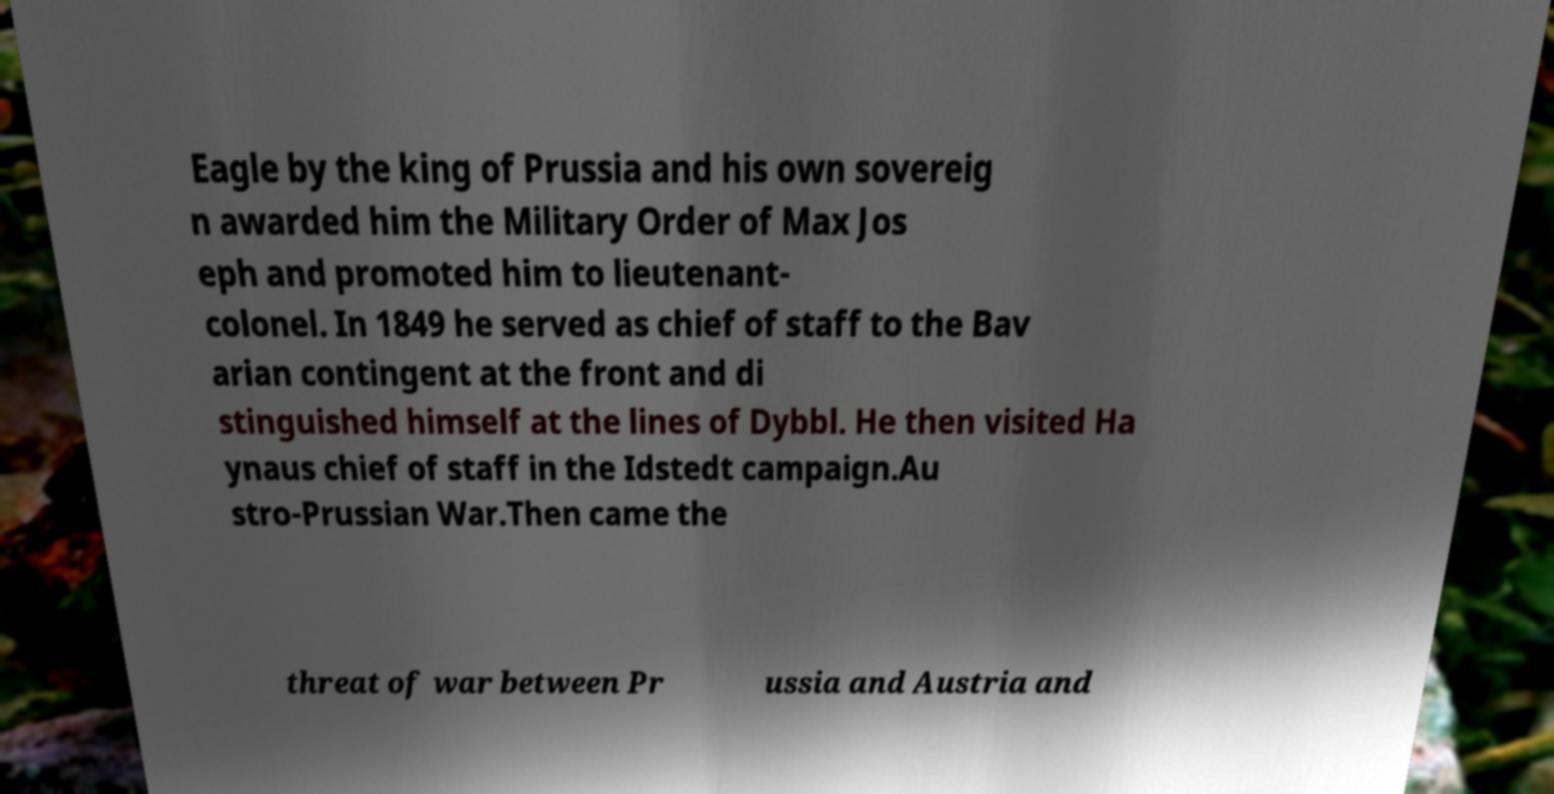Could you assist in decoding the text presented in this image and type it out clearly? Eagle by the king of Prussia and his own sovereig n awarded him the Military Order of Max Jos eph and promoted him to lieutenant- colonel. In 1849 he served as chief of staff to the Bav arian contingent at the front and di stinguished himself at the lines of Dybbl. He then visited Ha ynaus chief of staff in the Idstedt campaign.Au stro-Prussian War.Then came the threat of war between Pr ussia and Austria and 